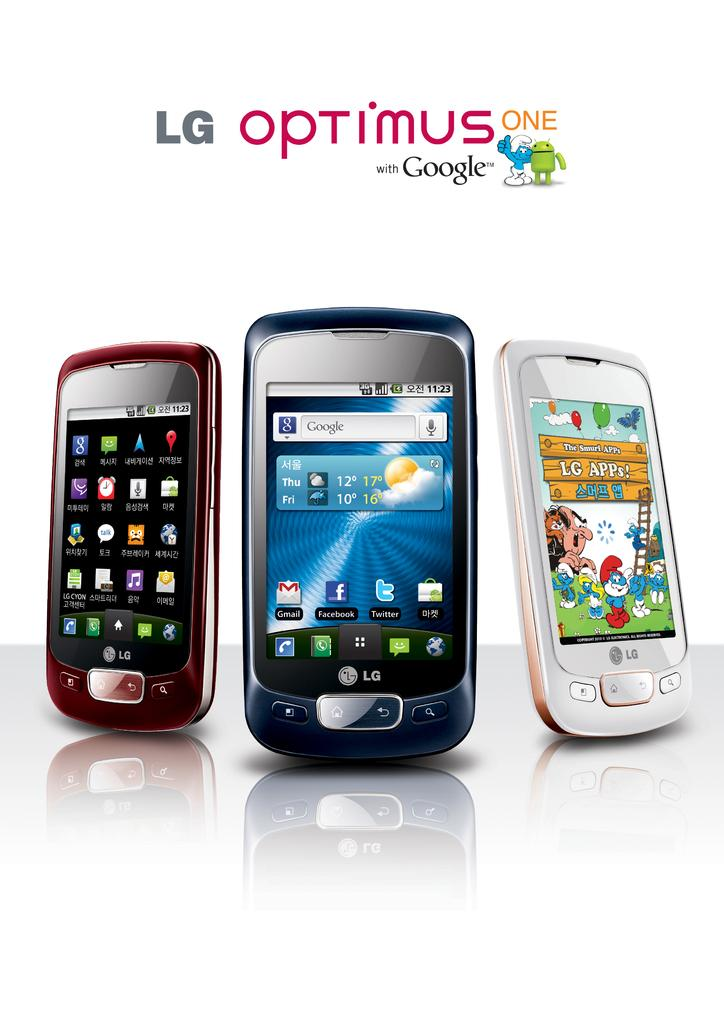<image>
Describe the image concisely. An ad for LG OPTIMUS ONE displaying three phones, red, black, and white, the white showing The Smurf APPs. 